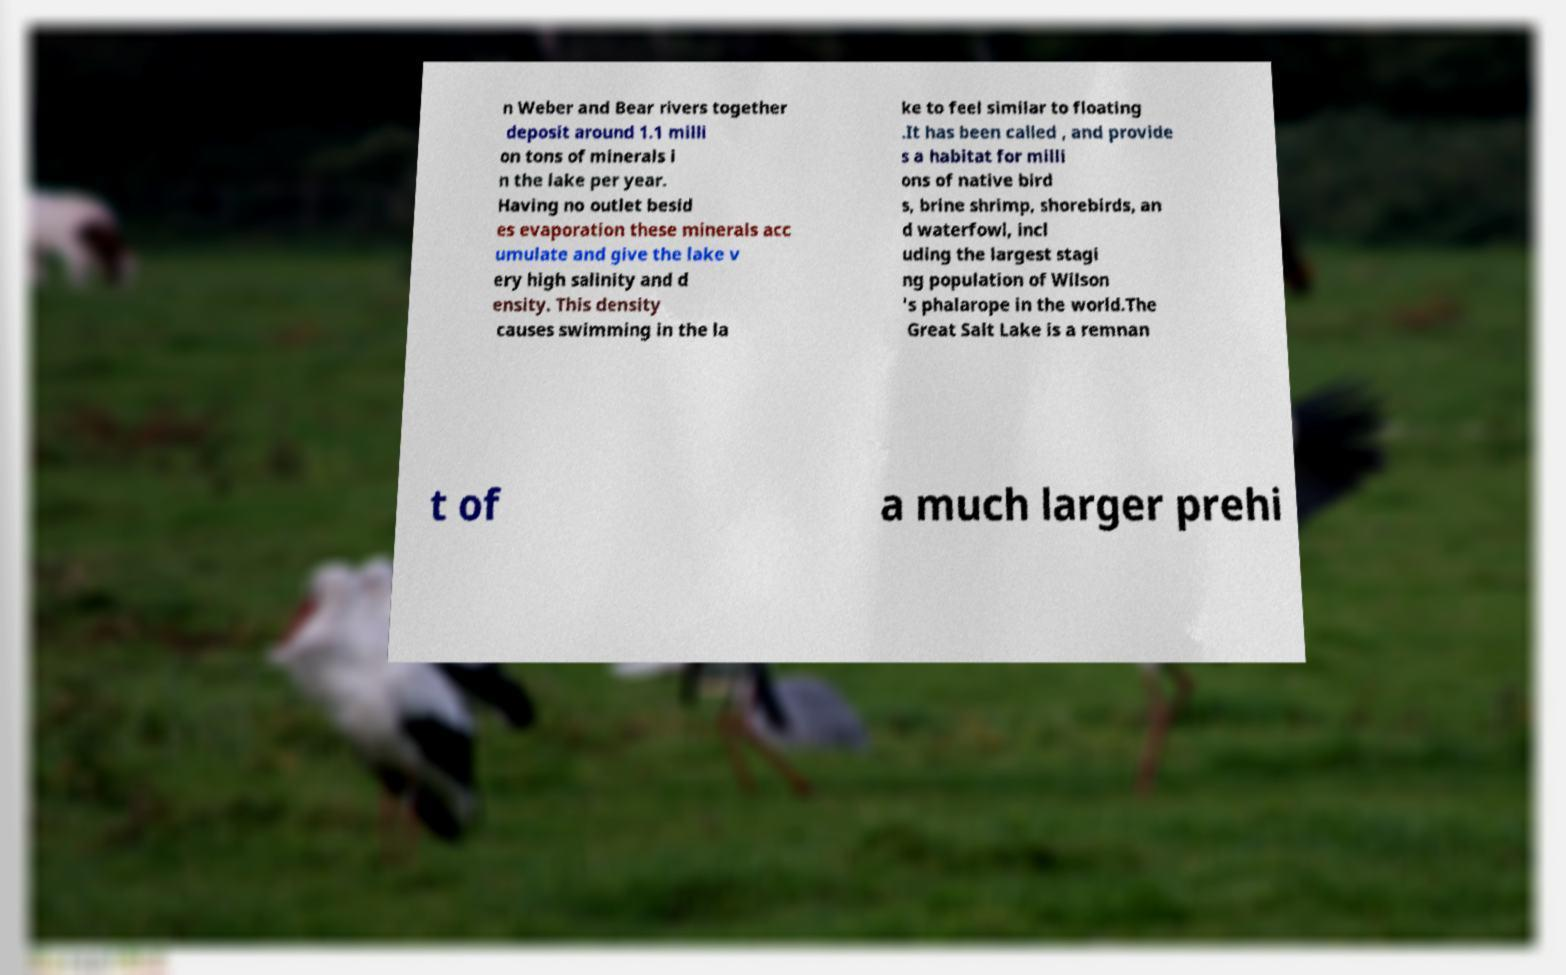Could you assist in decoding the text presented in this image and type it out clearly? n Weber and Bear rivers together deposit around 1.1 milli on tons of minerals i n the lake per year. Having no outlet besid es evaporation these minerals acc umulate and give the lake v ery high salinity and d ensity. This density causes swimming in the la ke to feel similar to floating .It has been called , and provide s a habitat for milli ons of native bird s, brine shrimp, shorebirds, an d waterfowl, incl uding the largest stagi ng population of Wilson 's phalarope in the world.The Great Salt Lake is a remnan t of a much larger prehi 